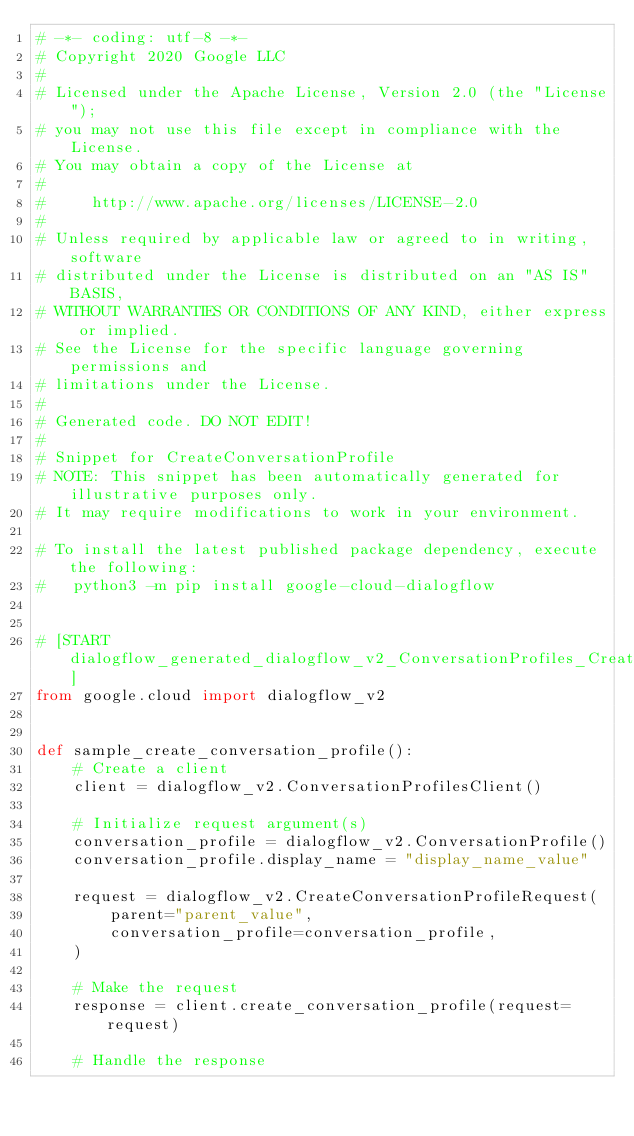<code> <loc_0><loc_0><loc_500><loc_500><_Python_># -*- coding: utf-8 -*-
# Copyright 2020 Google LLC
#
# Licensed under the Apache License, Version 2.0 (the "License");
# you may not use this file except in compliance with the License.
# You may obtain a copy of the License at
#
#     http://www.apache.org/licenses/LICENSE-2.0
#
# Unless required by applicable law or agreed to in writing, software
# distributed under the License is distributed on an "AS IS" BASIS,
# WITHOUT WARRANTIES OR CONDITIONS OF ANY KIND, either express or implied.
# See the License for the specific language governing permissions and
# limitations under the License.
#
# Generated code. DO NOT EDIT!
#
# Snippet for CreateConversationProfile
# NOTE: This snippet has been automatically generated for illustrative purposes only.
# It may require modifications to work in your environment.

# To install the latest published package dependency, execute the following:
#   python3 -m pip install google-cloud-dialogflow


# [START dialogflow_generated_dialogflow_v2_ConversationProfiles_CreateConversationProfile_sync]
from google.cloud import dialogflow_v2


def sample_create_conversation_profile():
    # Create a client
    client = dialogflow_v2.ConversationProfilesClient()

    # Initialize request argument(s)
    conversation_profile = dialogflow_v2.ConversationProfile()
    conversation_profile.display_name = "display_name_value"

    request = dialogflow_v2.CreateConversationProfileRequest(
        parent="parent_value",
        conversation_profile=conversation_profile,
    )

    # Make the request
    response = client.create_conversation_profile(request=request)

    # Handle the response</code> 